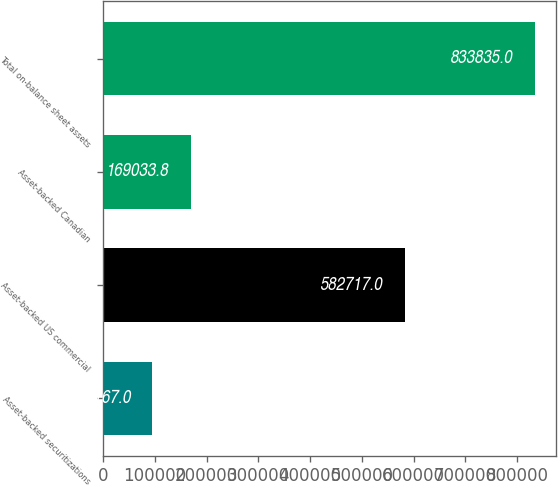Convert chart to OTSL. <chart><loc_0><loc_0><loc_500><loc_500><bar_chart><fcel>Asset-backed securitizations<fcel>Asset-backed US commercial<fcel>Asset-backed Canadian<fcel>Total on-balance sheet assets<nl><fcel>95167<fcel>582717<fcel>169034<fcel>833835<nl></chart> 